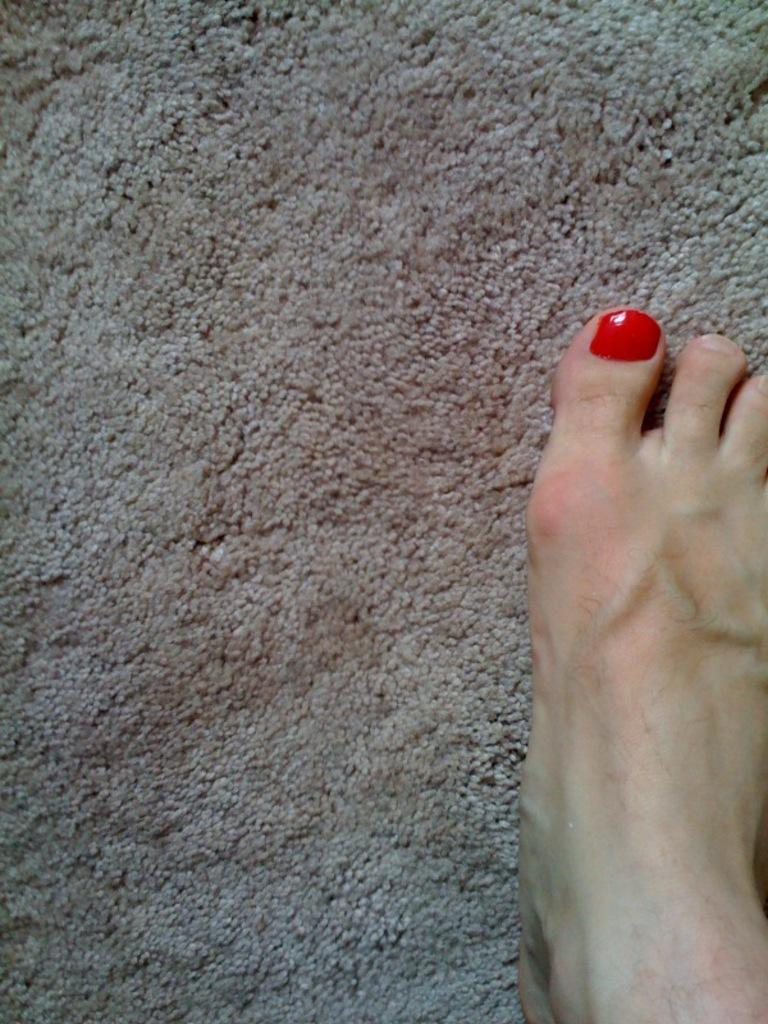What part of the body is visible in the image? There is a leg visible in the image. What is the leg resting on? The leg is on a surface. What color is the person's toenail polish on the leg? The person's toenail polish on the leg is red in color. How many quarters can be seen on the person's tooth in the image? There are no quarters or teeth visible in the image; only a leg is present. 